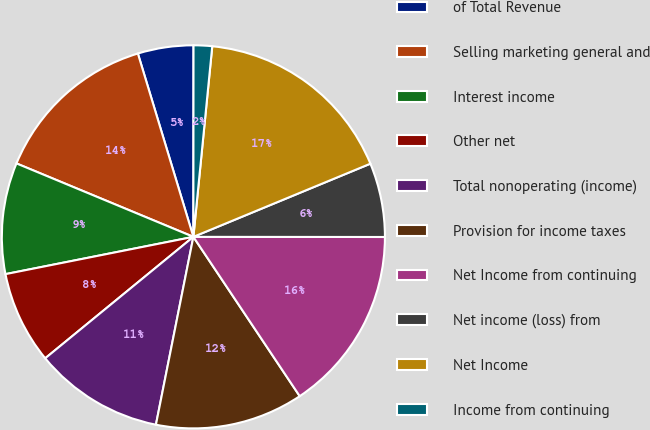Convert chart to OTSL. <chart><loc_0><loc_0><loc_500><loc_500><pie_chart><fcel>of Total Revenue<fcel>Selling marketing general and<fcel>Interest income<fcel>Other net<fcel>Total nonoperating (income)<fcel>Provision for income taxes<fcel>Net Income from continuing<fcel>Net income (loss) from<fcel>Net Income<fcel>Income from continuing<nl><fcel>4.69%<fcel>14.06%<fcel>9.38%<fcel>7.81%<fcel>10.94%<fcel>12.5%<fcel>15.62%<fcel>6.25%<fcel>17.19%<fcel>1.56%<nl></chart> 